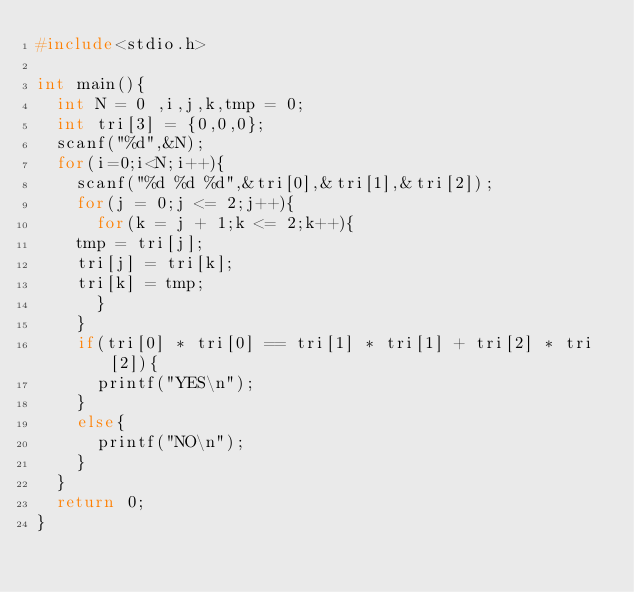Convert code to text. <code><loc_0><loc_0><loc_500><loc_500><_C_>#include<stdio.h>

int main(){
  int N = 0 ,i,j,k,tmp = 0;
  int tri[3] = {0,0,0};
  scanf("%d",&N);
  for(i=0;i<N;i++){
    scanf("%d %d %d",&tri[0],&tri[1],&tri[2]);
    for(j = 0;j <= 2;j++){
      for(k = j + 1;k <= 2;k++){
	tmp = tri[j];
	tri[j] = tri[k];
	tri[k] = tmp;
      }
    }
    if(tri[0] * tri[0] == tri[1] * tri[1] + tri[2] * tri[2]){
      printf("YES\n");
    }
    else{
      printf("NO\n");
    }
  }
  return 0;
}  
    </code> 